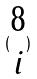<formula> <loc_0><loc_0><loc_500><loc_500>( \begin{matrix} 8 \\ i \end{matrix} )</formula> 